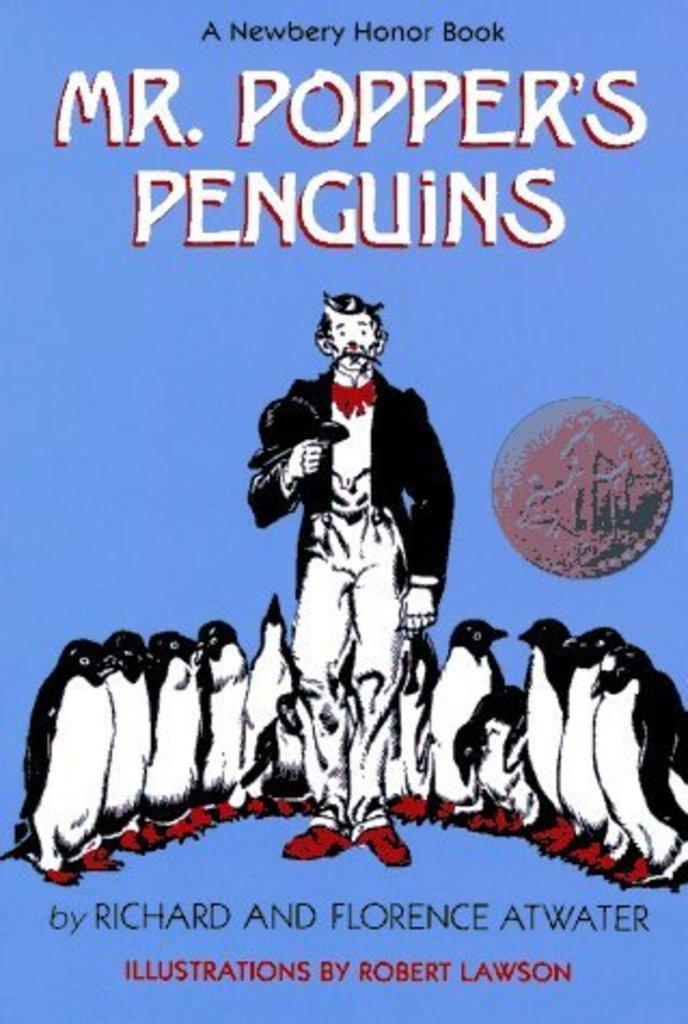<image>
Give a short and clear explanation of the subsequent image. The book Mr. Poppers Penguins with a blue cover featuring Mr. Popper and some of his penguins. 